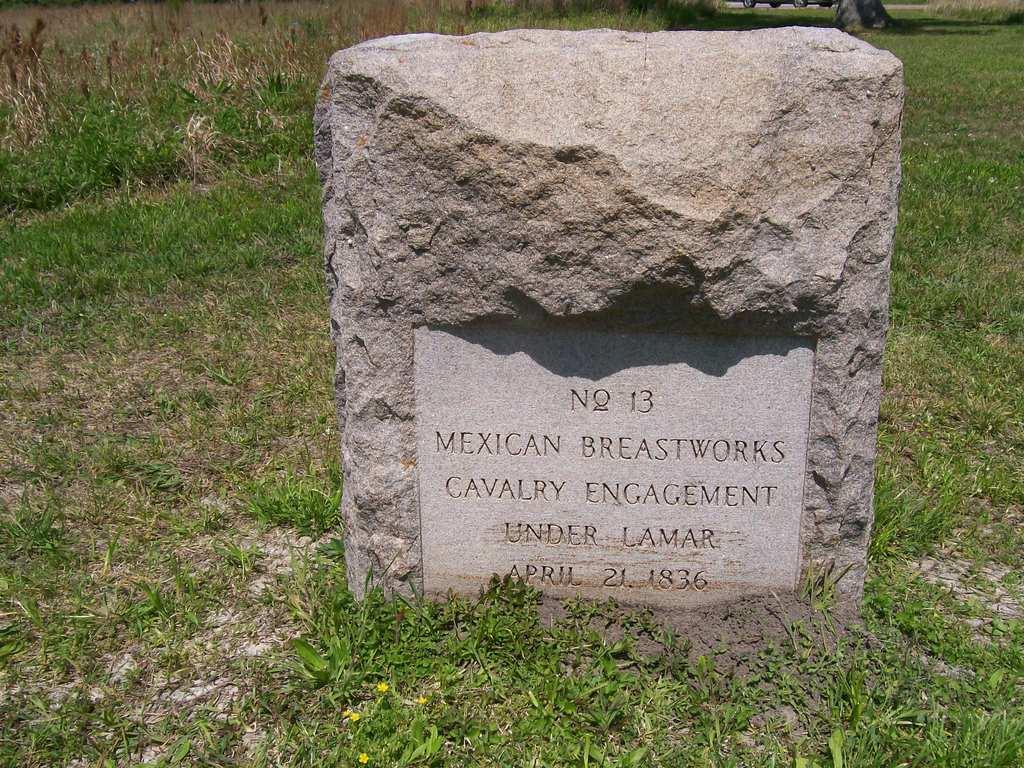What is the main object in the image? There is a headstone in the image. What is written or carved on the headstone? There is text carved on the headstone. What type of ground is visible in the image? There is grass on the ground in the image. Can you see a chain attached to the headstone in the image? No, there is no chain visible in the image. Are there any chickens walking around the headstone in the image? No, there are no chickens present in the image. 